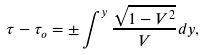Convert formula to latex. <formula><loc_0><loc_0><loc_500><loc_500>\tau - \tau _ { o } = \pm \int ^ { y } \frac { \sqrt { 1 - V ^ { 2 } } } { V } d y ,</formula> 